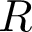Convert formula to latex. <formula><loc_0><loc_0><loc_500><loc_500>R</formula> 